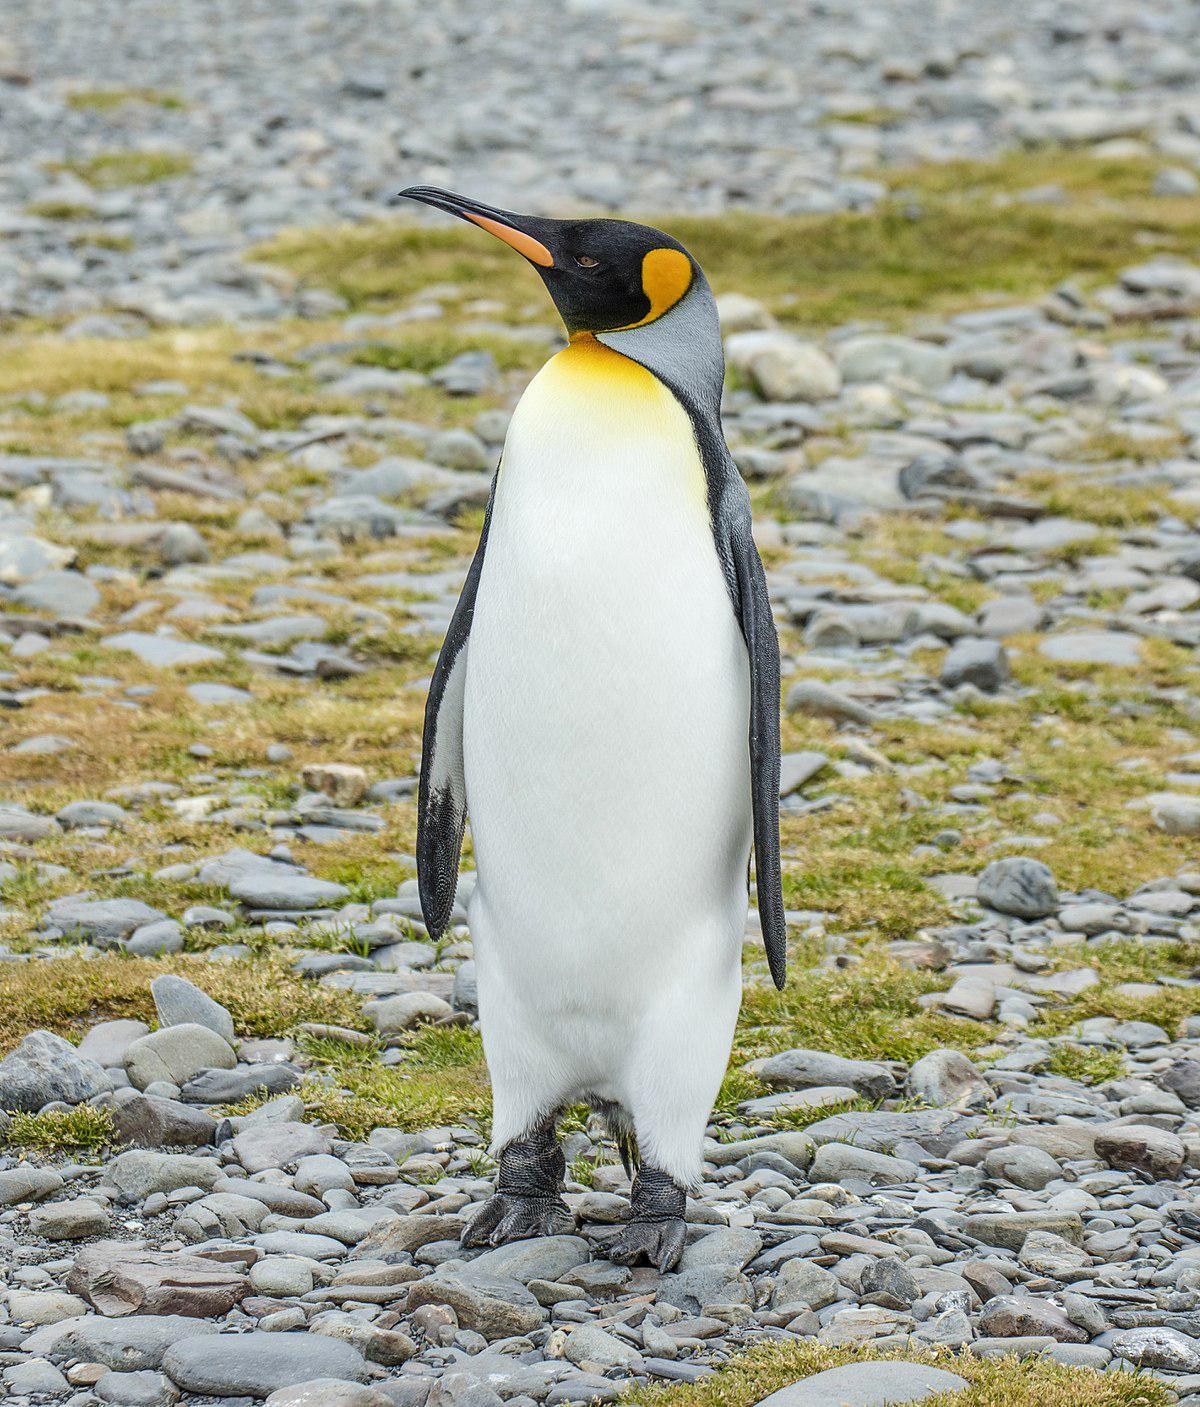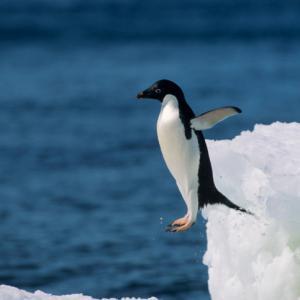The first image is the image on the left, the second image is the image on the right. Evaluate the accuracy of this statement regarding the images: "A total of two penguins are on both images.". Is it true? Answer yes or no. Yes. 